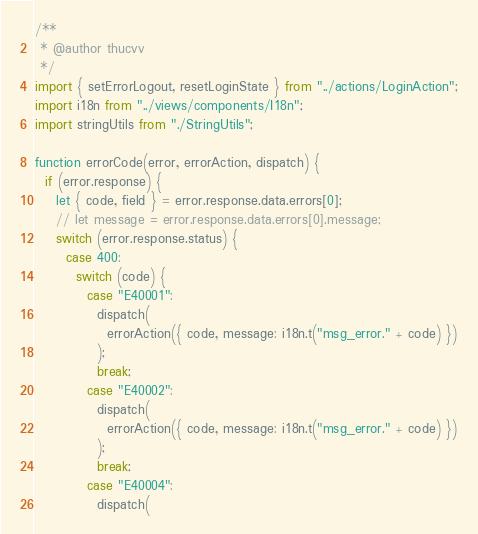<code> <loc_0><loc_0><loc_500><loc_500><_JavaScript_>/**
 * @author thucvv
 */
import { setErrorLogout, resetLoginState } from "../actions/LoginAction";
import i18n from "../views/components/I18n";
import stringUtils from "./StringUtils";

function errorCode(error, errorAction, dispatch) {
  if (error.response) {
    let { code, field } = error.response.data.errors[0];
    // let message = error.response.data.errors[0].message;
    switch (error.response.status) {
      case 400:
        switch (code) {
          case "E40001":
            dispatch(
              errorAction({ code, message: i18n.t("msg_error." + code) })
            );
            break;
          case "E40002":
            dispatch(
              errorAction({ code, message: i18n.t("msg_error." + code) })
            );
            break;
          case "E40004":
            dispatch(</code> 